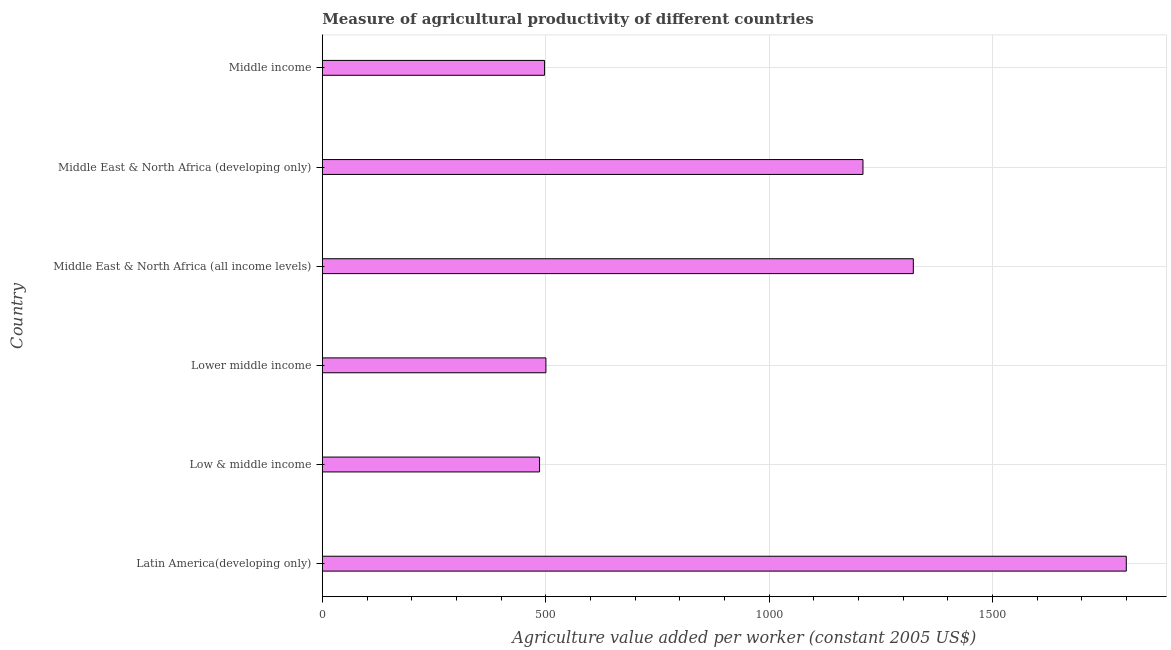Does the graph contain grids?
Ensure brevity in your answer.  Yes. What is the title of the graph?
Provide a short and direct response. Measure of agricultural productivity of different countries. What is the label or title of the X-axis?
Give a very brief answer. Agriculture value added per worker (constant 2005 US$). What is the agriculture value added per worker in Latin America(developing only)?
Give a very brief answer. 1799.54. Across all countries, what is the maximum agriculture value added per worker?
Give a very brief answer. 1799.54. Across all countries, what is the minimum agriculture value added per worker?
Your answer should be compact. 486.23. In which country was the agriculture value added per worker maximum?
Provide a short and direct response. Latin America(developing only). What is the sum of the agriculture value added per worker?
Offer a terse response. 5816.64. What is the difference between the agriculture value added per worker in Middle East & North Africa (all income levels) and Middle income?
Make the answer very short. 825.38. What is the average agriculture value added per worker per country?
Give a very brief answer. 969.44. What is the median agriculture value added per worker?
Ensure brevity in your answer.  855.28. What is the ratio of the agriculture value added per worker in Latin America(developing only) to that in Low & middle income?
Provide a short and direct response. 3.7. Is the difference between the agriculture value added per worker in Low & middle income and Lower middle income greater than the difference between any two countries?
Ensure brevity in your answer.  No. What is the difference between the highest and the second highest agriculture value added per worker?
Make the answer very short. 476.69. What is the difference between the highest and the lowest agriculture value added per worker?
Your answer should be very brief. 1313.32. Are all the bars in the graph horizontal?
Keep it short and to the point. Yes. What is the difference between two consecutive major ticks on the X-axis?
Keep it short and to the point. 500. What is the Agriculture value added per worker (constant 2005 US$) in Latin America(developing only)?
Make the answer very short. 1799.54. What is the Agriculture value added per worker (constant 2005 US$) of Low & middle income?
Give a very brief answer. 486.23. What is the Agriculture value added per worker (constant 2005 US$) in Lower middle income?
Keep it short and to the point. 500.44. What is the Agriculture value added per worker (constant 2005 US$) in Middle East & North Africa (all income levels)?
Make the answer very short. 1322.85. What is the Agriculture value added per worker (constant 2005 US$) of Middle East & North Africa (developing only)?
Offer a very short reply. 1210.12. What is the Agriculture value added per worker (constant 2005 US$) of Middle income?
Give a very brief answer. 497.47. What is the difference between the Agriculture value added per worker (constant 2005 US$) in Latin America(developing only) and Low & middle income?
Make the answer very short. 1313.32. What is the difference between the Agriculture value added per worker (constant 2005 US$) in Latin America(developing only) and Lower middle income?
Keep it short and to the point. 1299.1. What is the difference between the Agriculture value added per worker (constant 2005 US$) in Latin America(developing only) and Middle East & North Africa (all income levels)?
Your response must be concise. 476.69. What is the difference between the Agriculture value added per worker (constant 2005 US$) in Latin America(developing only) and Middle East & North Africa (developing only)?
Offer a very short reply. 589.43. What is the difference between the Agriculture value added per worker (constant 2005 US$) in Latin America(developing only) and Middle income?
Give a very brief answer. 1302.07. What is the difference between the Agriculture value added per worker (constant 2005 US$) in Low & middle income and Lower middle income?
Keep it short and to the point. -14.21. What is the difference between the Agriculture value added per worker (constant 2005 US$) in Low & middle income and Middle East & North Africa (all income levels)?
Provide a succinct answer. -836.62. What is the difference between the Agriculture value added per worker (constant 2005 US$) in Low & middle income and Middle East & North Africa (developing only)?
Provide a short and direct response. -723.89. What is the difference between the Agriculture value added per worker (constant 2005 US$) in Low & middle income and Middle income?
Make the answer very short. -11.24. What is the difference between the Agriculture value added per worker (constant 2005 US$) in Lower middle income and Middle East & North Africa (all income levels)?
Keep it short and to the point. -822.41. What is the difference between the Agriculture value added per worker (constant 2005 US$) in Lower middle income and Middle East & North Africa (developing only)?
Keep it short and to the point. -709.68. What is the difference between the Agriculture value added per worker (constant 2005 US$) in Lower middle income and Middle income?
Make the answer very short. 2.97. What is the difference between the Agriculture value added per worker (constant 2005 US$) in Middle East & North Africa (all income levels) and Middle East & North Africa (developing only)?
Your answer should be very brief. 112.73. What is the difference between the Agriculture value added per worker (constant 2005 US$) in Middle East & North Africa (all income levels) and Middle income?
Your answer should be compact. 825.38. What is the difference between the Agriculture value added per worker (constant 2005 US$) in Middle East & North Africa (developing only) and Middle income?
Make the answer very short. 712.65. What is the ratio of the Agriculture value added per worker (constant 2005 US$) in Latin America(developing only) to that in Low & middle income?
Offer a terse response. 3.7. What is the ratio of the Agriculture value added per worker (constant 2005 US$) in Latin America(developing only) to that in Lower middle income?
Your answer should be compact. 3.6. What is the ratio of the Agriculture value added per worker (constant 2005 US$) in Latin America(developing only) to that in Middle East & North Africa (all income levels)?
Give a very brief answer. 1.36. What is the ratio of the Agriculture value added per worker (constant 2005 US$) in Latin America(developing only) to that in Middle East & North Africa (developing only)?
Provide a short and direct response. 1.49. What is the ratio of the Agriculture value added per worker (constant 2005 US$) in Latin America(developing only) to that in Middle income?
Offer a terse response. 3.62. What is the ratio of the Agriculture value added per worker (constant 2005 US$) in Low & middle income to that in Lower middle income?
Provide a short and direct response. 0.97. What is the ratio of the Agriculture value added per worker (constant 2005 US$) in Low & middle income to that in Middle East & North Africa (all income levels)?
Your response must be concise. 0.37. What is the ratio of the Agriculture value added per worker (constant 2005 US$) in Low & middle income to that in Middle East & North Africa (developing only)?
Your answer should be very brief. 0.4. What is the ratio of the Agriculture value added per worker (constant 2005 US$) in Low & middle income to that in Middle income?
Ensure brevity in your answer.  0.98. What is the ratio of the Agriculture value added per worker (constant 2005 US$) in Lower middle income to that in Middle East & North Africa (all income levels)?
Give a very brief answer. 0.38. What is the ratio of the Agriculture value added per worker (constant 2005 US$) in Lower middle income to that in Middle East & North Africa (developing only)?
Your answer should be very brief. 0.41. What is the ratio of the Agriculture value added per worker (constant 2005 US$) in Middle East & North Africa (all income levels) to that in Middle East & North Africa (developing only)?
Offer a very short reply. 1.09. What is the ratio of the Agriculture value added per worker (constant 2005 US$) in Middle East & North Africa (all income levels) to that in Middle income?
Give a very brief answer. 2.66. What is the ratio of the Agriculture value added per worker (constant 2005 US$) in Middle East & North Africa (developing only) to that in Middle income?
Your answer should be compact. 2.43. 